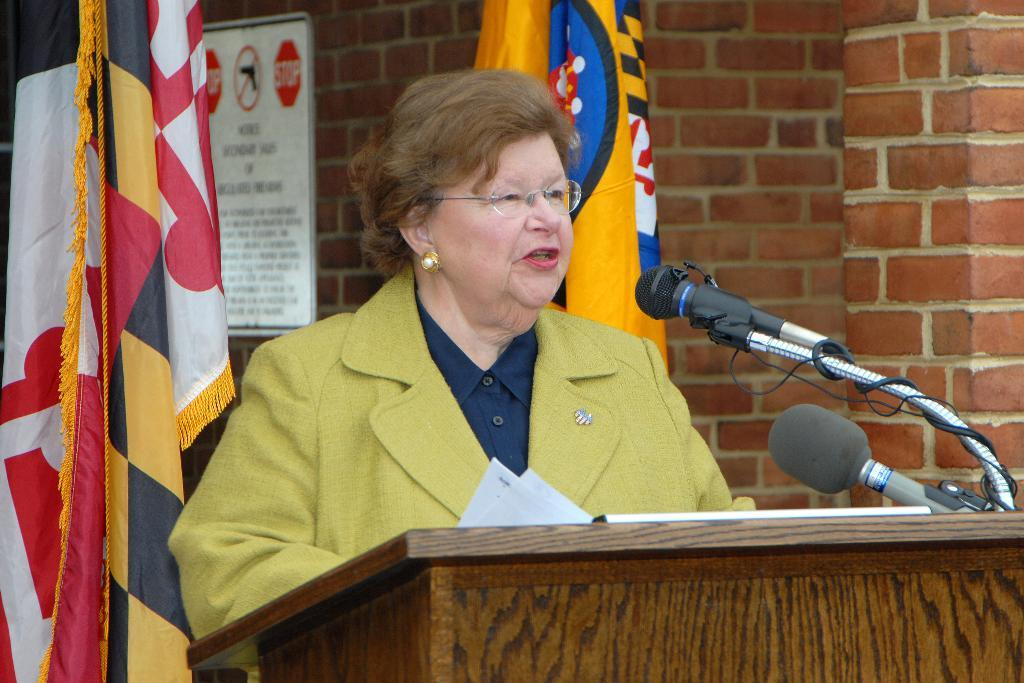Who is the main subject in the image? There is a woman in the image. What is the woman wearing? The woman is wearing a blazer and spectacles. What is the woman doing in the image? The woman is standing at a podium and speaking into a microphone. What can be seen in the background of the image? There are flags and a poster on the wall in the background. What type of stocking is the woman wearing in the image? There is no mention of stockings in the provided facts, so we cannot determine if the woman is wearing any. Can you see a tent in the background of the image? No, there is no tent present in the image; only flags and a poster on the wall are visible in the background. 